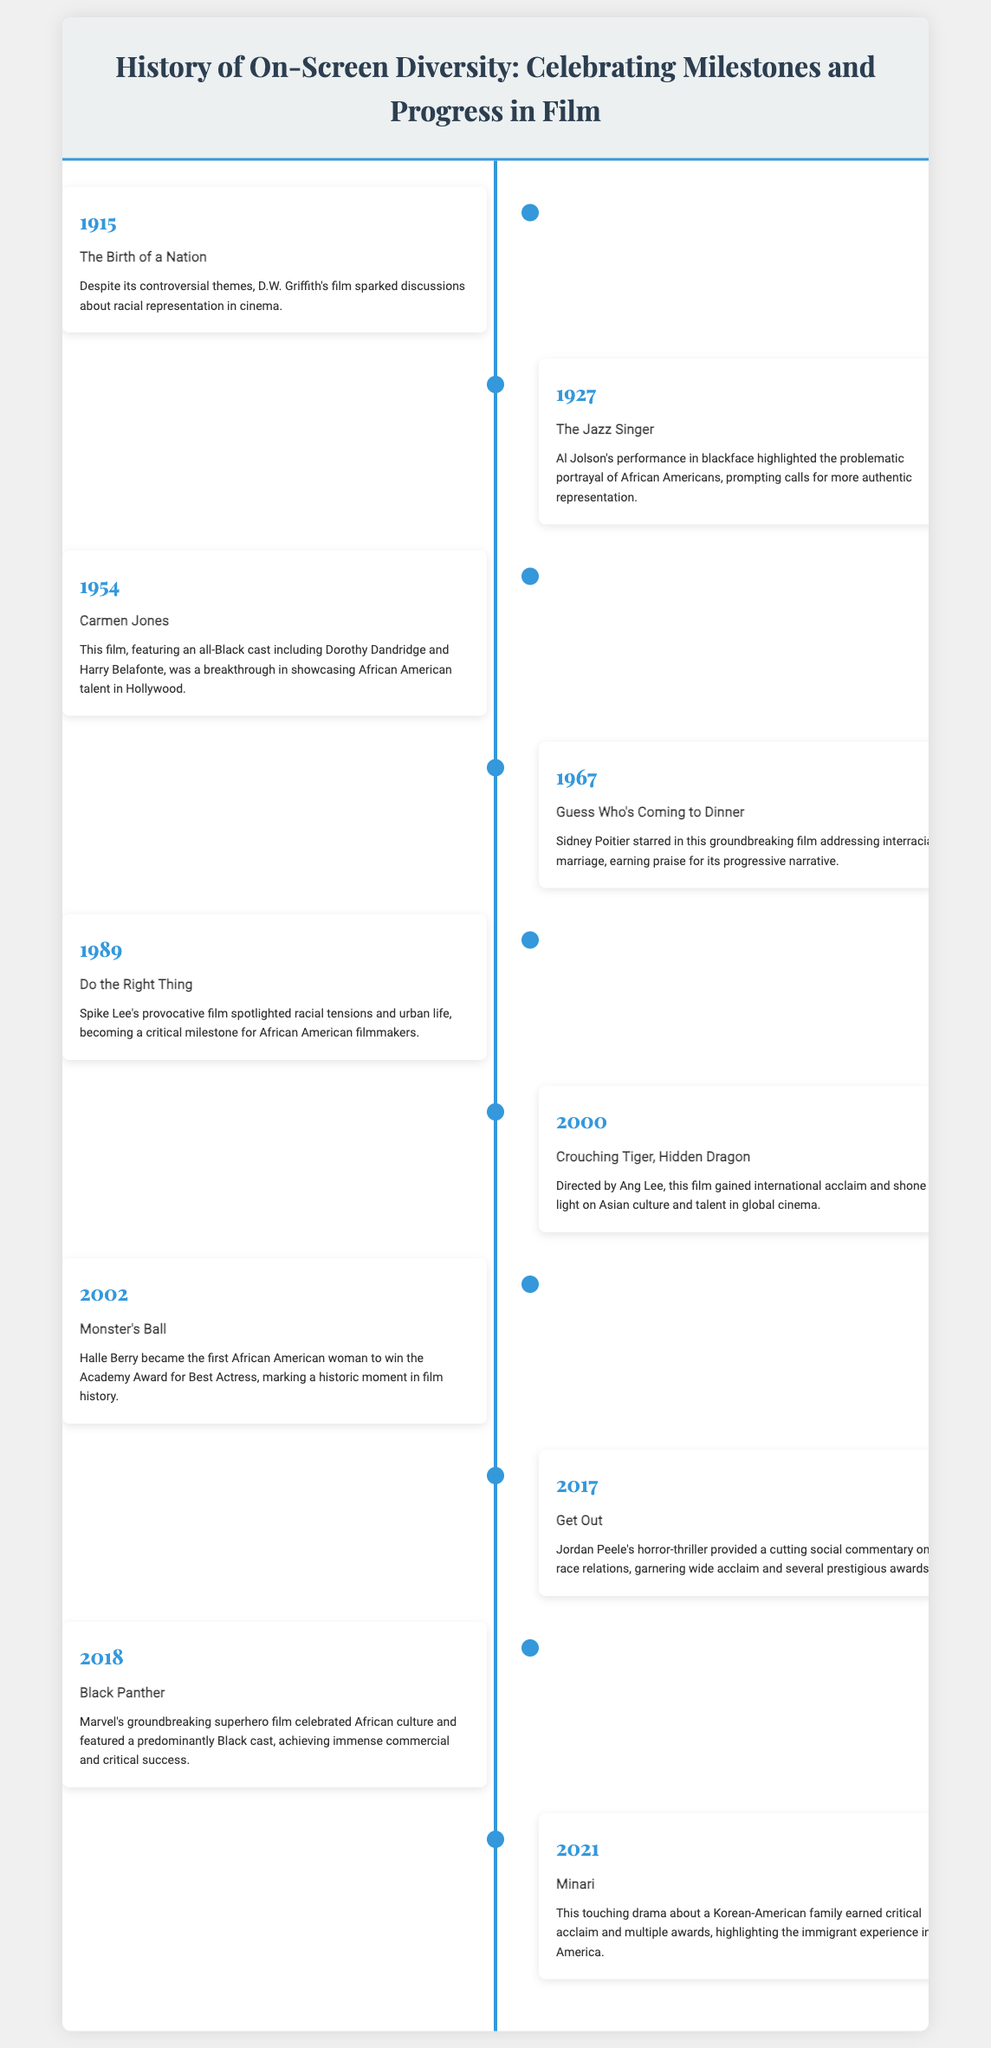what year was "The Birth of a Nation" released? "The Birth of a Nation" is listed in the document with the year 1915.
Answer: 1915 who starred in "Guess Who's Coming to Dinner"? The document states that Sidney Poitier starred in this film.
Answer: Sidney Poitier what milestone did Halle Berry achieve in 2002? The document notes that Halle Berry became the first African American woman to win the Academy Award for Best Actress.
Answer: First African American woman to win Best Actress which film highlighted Asian culture and talent? According to the timeline, "Crouching Tiger, Hidden Dragon" directed by Ang Lee achieved this recognition.
Answer: Crouching Tiger, Hidden Dragon what significant theme is addressed in "Do the Right Thing"? The film is noted for spotlighting racial tensions and urban life in America.
Answer: Racial tensions which film celebrated African culture? "Black Panther" is mentioned in the document as celebrating African culture.
Answer: Black Panther what year did "Get Out" receive acclaim? The timeline indicates that "Get Out" was significant in 2017.
Answer: 2017 how many films featured an all-Black cast according to the timeline? "Carmen Jones" and "Black Panther" both feature all-Black or predominantly Black casts.
Answer: Two films what is the primary focus of the timeline infographic? The document details milestones and progress related to on-screen diversity in film.
Answer: On-screen diversity 